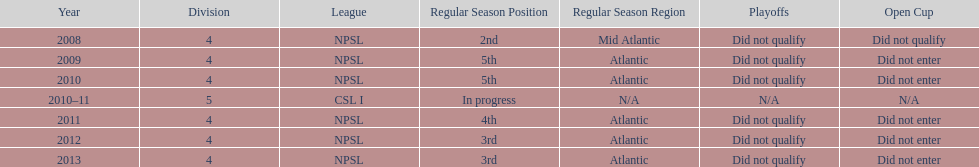What is the lowest place they came in 5th. 